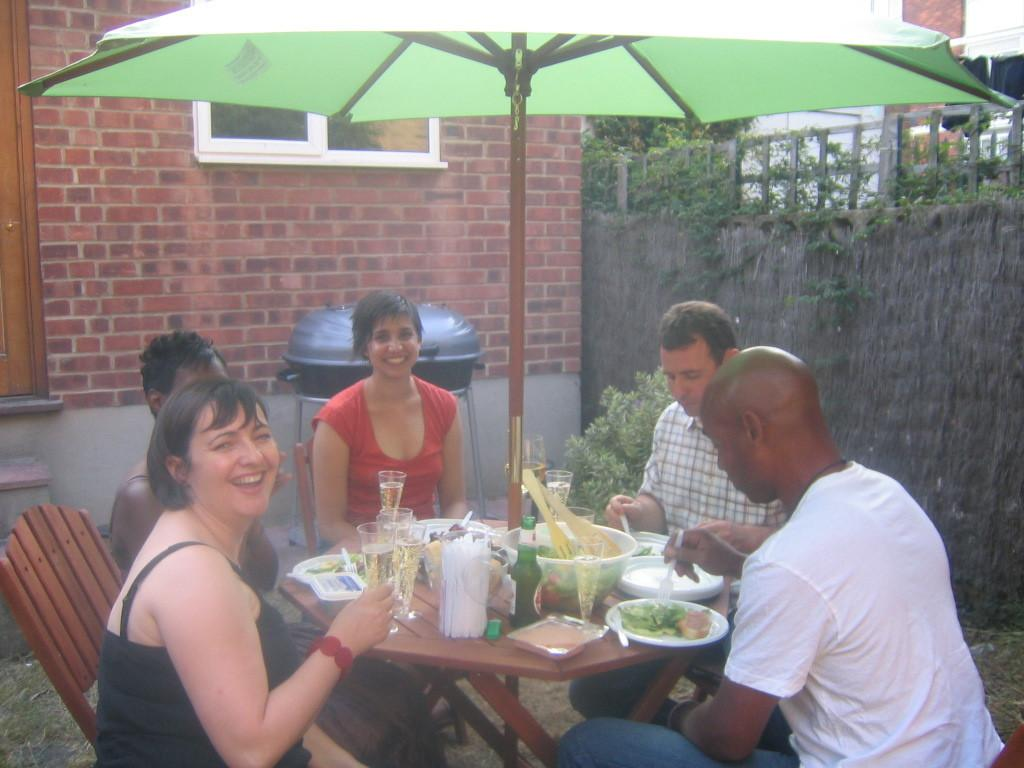What is happening in the image? There are people sitting around the table in the image. What can be seen on the table? There are many objects on the table in the image. Can you describe the umbrella in the image? There is an umbrella in the image. What is visible in the background of the image? There is a wall in the background of the image. How many children are playing with the umbrella in the image? There are no children present in the image, and the umbrella is not being used for play. 